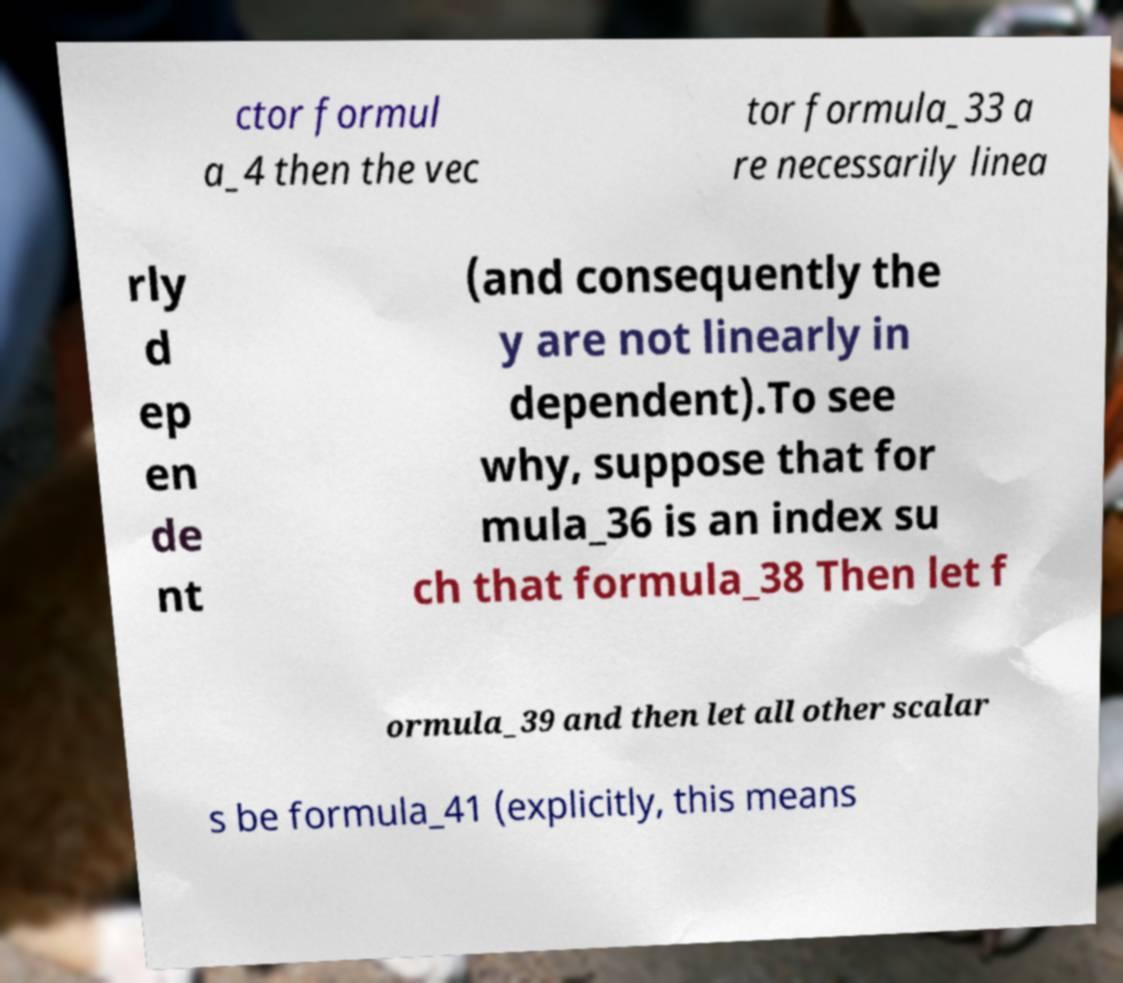Could you assist in decoding the text presented in this image and type it out clearly? ctor formul a_4 then the vec tor formula_33 a re necessarily linea rly d ep en de nt (and consequently the y are not linearly in dependent).To see why, suppose that for mula_36 is an index su ch that formula_38 Then let f ormula_39 and then let all other scalar s be formula_41 (explicitly, this means 